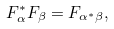Convert formula to latex. <formula><loc_0><loc_0><loc_500><loc_500>F _ { \alpha } ^ { * } F _ { \beta } = F _ { \alpha ^ { * } \beta } ,</formula> 